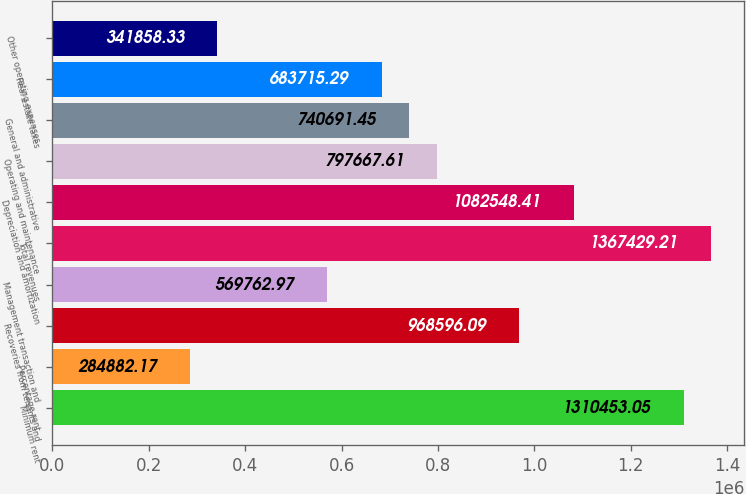Convert chart to OTSL. <chart><loc_0><loc_0><loc_500><loc_500><bar_chart><fcel>Minimum rent<fcel>Percentage rent<fcel>Recoveries from tenants and<fcel>Management transaction and<fcel>Total revenues<fcel>Depreciation and amortization<fcel>Operating and maintenance<fcel>General and administrative<fcel>Real estate taxes<fcel>Other operating expenses<nl><fcel>1.31045e+06<fcel>284882<fcel>968596<fcel>569763<fcel>1.36743e+06<fcel>1.08255e+06<fcel>797668<fcel>740691<fcel>683715<fcel>341858<nl></chart> 